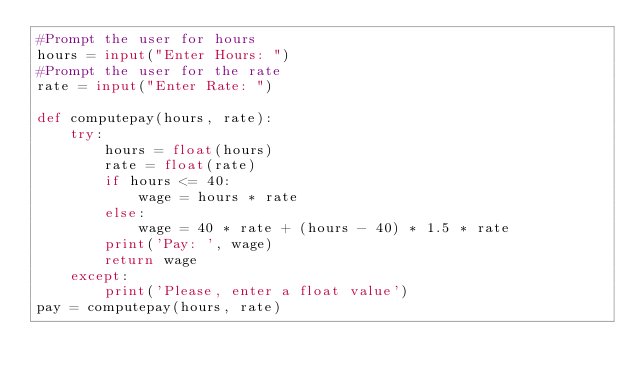<code> <loc_0><loc_0><loc_500><loc_500><_Python_>#Prompt the user for hours
hours = input("Enter Hours: ")
#Prompt the user for the rate
rate = input("Enter Rate: ")

def computepay(hours, rate):
    try:
        hours = float(hours)
        rate = float(rate)
        if hours <= 40:
            wage = hours * rate
        else:
            wage = 40 * rate + (hours - 40) * 1.5 * rate
        print('Pay: ', wage)
        return wage
    except:
        print('Please, enter a float value')
pay = computepay(hours, rate)
</code> 